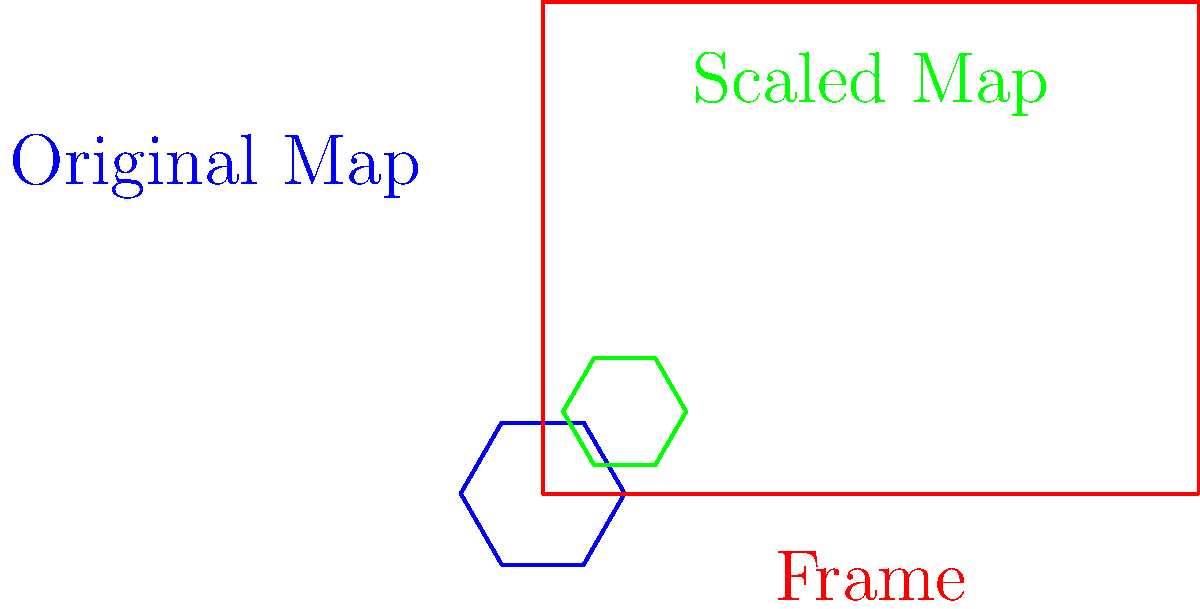As an aspiring novelist inspired by Shehan Karunatilaka's vivid descriptions of Colombo, you're working on a story set in the city. You have a stylized hexagonal map of Colombo that needs to fit within a rectangular frame for your book's frontispiece. The frame measures 4 units wide and 3 units tall, while the map's current width is 6 units. What scale factor should you apply to the map to make it fit perfectly within the frame, touching at least two sides? Let's approach this step-by-step:

1) First, we need to understand what "fit perfectly" means. In this context, it means the map should touch at least two sides of the frame without exceeding it.

2) The frame's dimensions are 4 units wide and 3 units tall. The map's current width is 6 units.

3) To find the scale factor, we need to consider both the width and height:

   For width: $\frac{4}{6} = \frac{2}{3} \approx 0.667$
   For height: We don't know the original height, so we can't calculate this yet.

4) Let's assume the height is the limiting factor. In this case, the scale factor would be $\frac{3}{h}$, where $h$ is the original height of the map.

5) For the map to fit perfectly, these scale factors should be equal:

   $\frac{2}{3} = \frac{3}{h}$

6) Cross-multiply:

   $2h = 9$

7) Solve for $h$:

   $h = \frac{9}{2} = 4.5$

8) Now we can confirm that the width is indeed the limiting factor, as scaling by $\frac{2}{3}$ will make the map touch the sides of the frame while leaving some space at the top and bottom.

Therefore, the scale factor we should apply is $\frac{2}{3}$ or approximately 0.667.
Answer: $\frac{2}{3}$ 